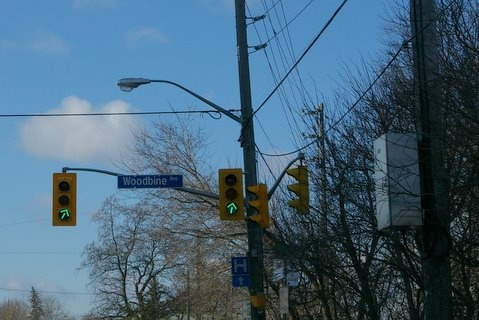Describe the objects in this image and their specific colors. I can see traffic light in gray, black, and darkgreen tones, traffic light in gray, maroon, black, and olive tones, traffic light in gray, black, and olive tones, and traffic light in gray, black, darkgreen, and blue tones in this image. 